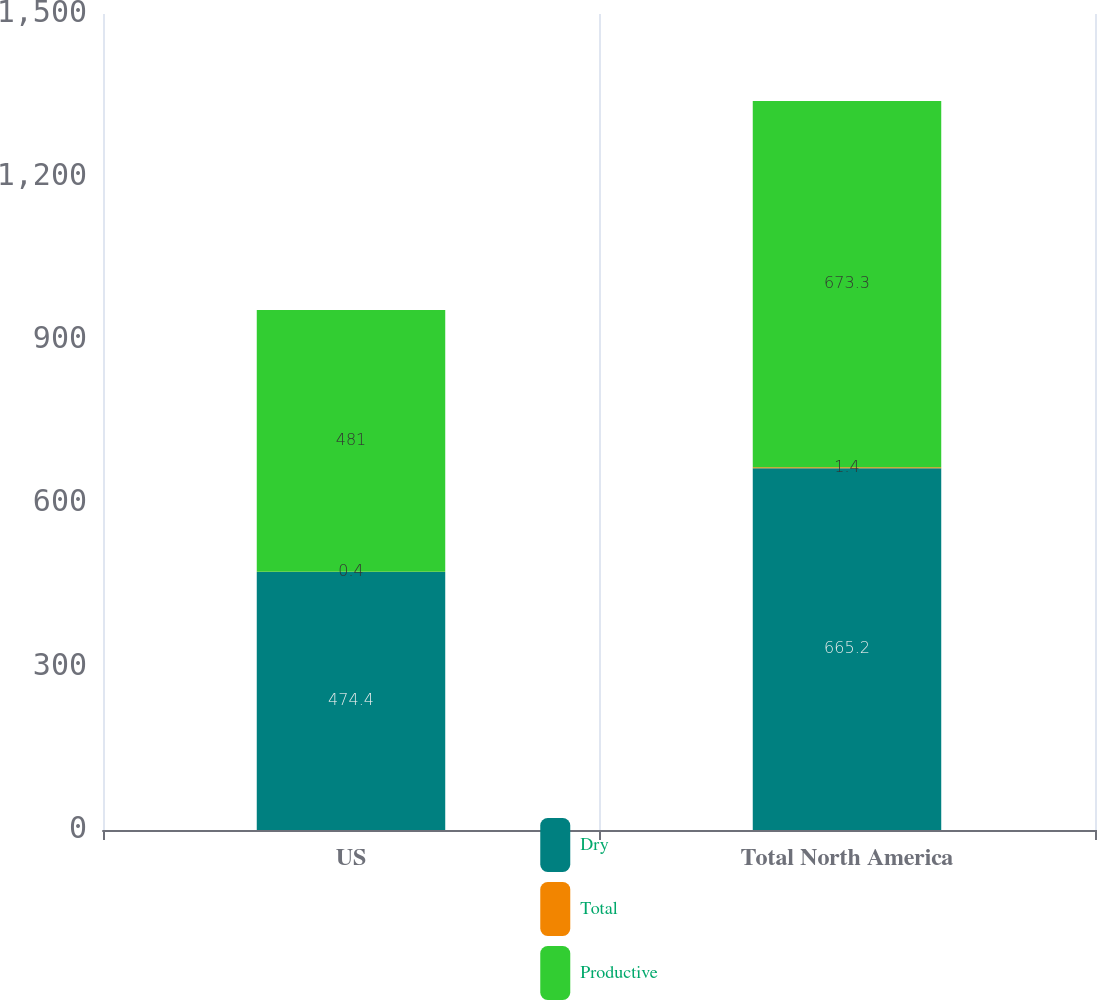Convert chart to OTSL. <chart><loc_0><loc_0><loc_500><loc_500><stacked_bar_chart><ecel><fcel>US<fcel>Total North America<nl><fcel>Dry<fcel>474.4<fcel>665.2<nl><fcel>Total<fcel>0.4<fcel>1.4<nl><fcel>Productive<fcel>481<fcel>673.3<nl></chart> 